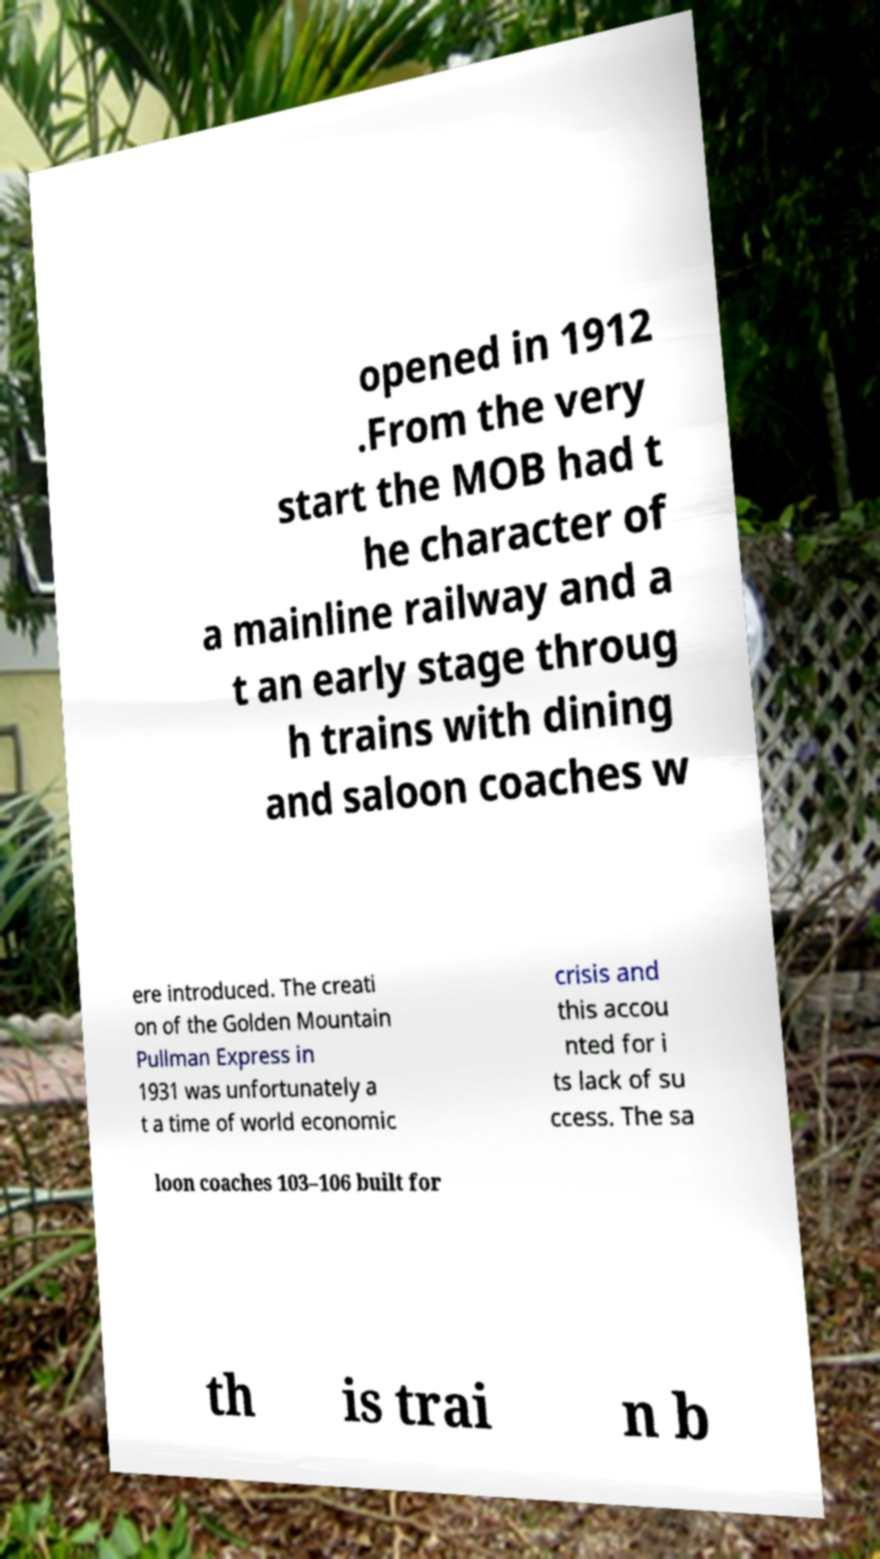For documentation purposes, I need the text within this image transcribed. Could you provide that? opened in 1912 .From the very start the MOB had t he character of a mainline railway and a t an early stage throug h trains with dining and saloon coaches w ere introduced. The creati on of the Golden Mountain Pullman Express in 1931 was unfortunately a t a time of world economic crisis and this accou nted for i ts lack of su ccess. The sa loon coaches 103–106 built for th is trai n b 